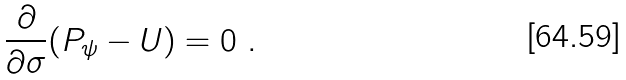Convert formula to latex. <formula><loc_0><loc_0><loc_500><loc_500>\frac { \partial } { \partial \sigma } ( P _ { \psi } - U ) = 0 \ .</formula> 